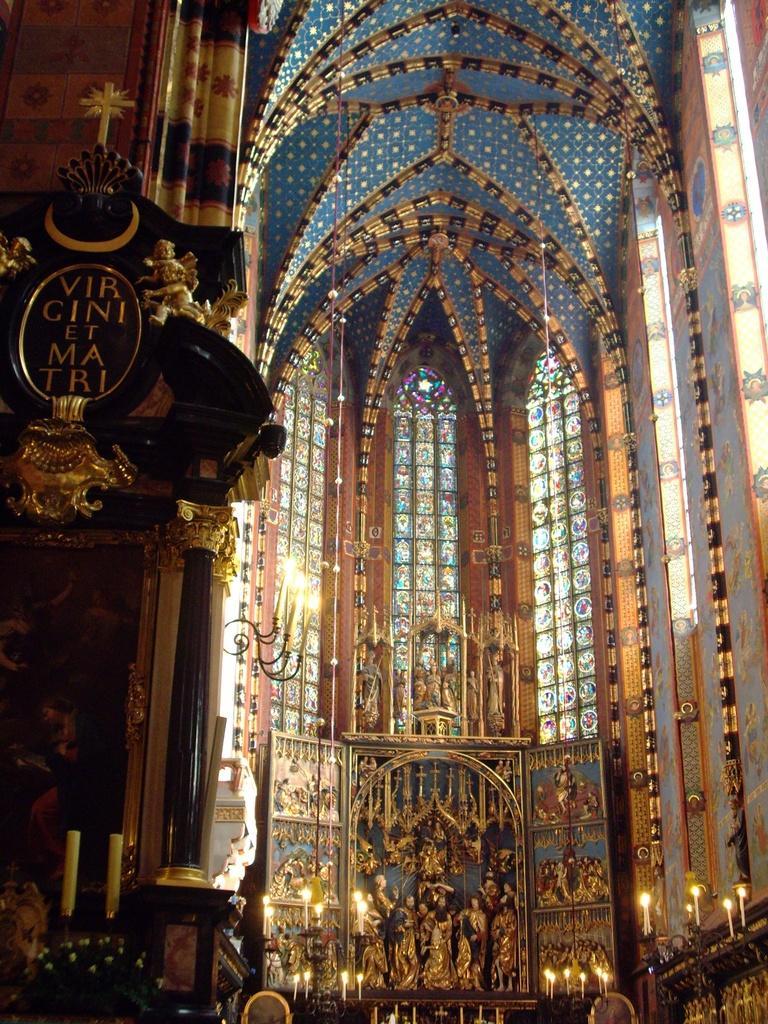Can you describe this image briefly? This picture shows inner view of a building. We see designer glass and few statues. 